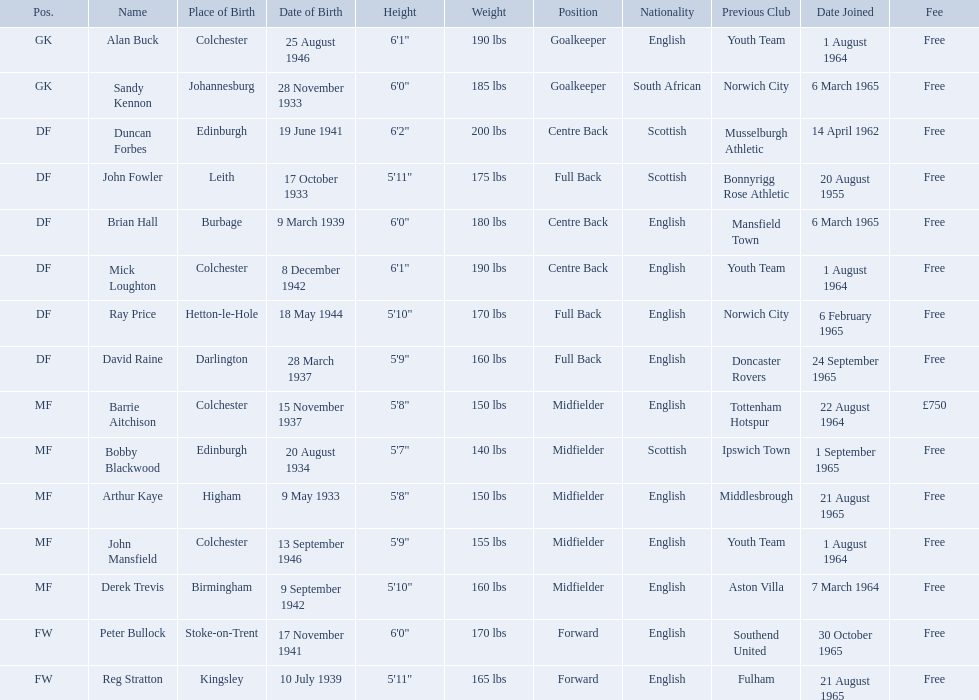When did alan buck join the colchester united f.c. in 1965-66? 1 August 1964. When did the last player to join? Peter Bullock. What date did the first player join? 20 August 1955. 